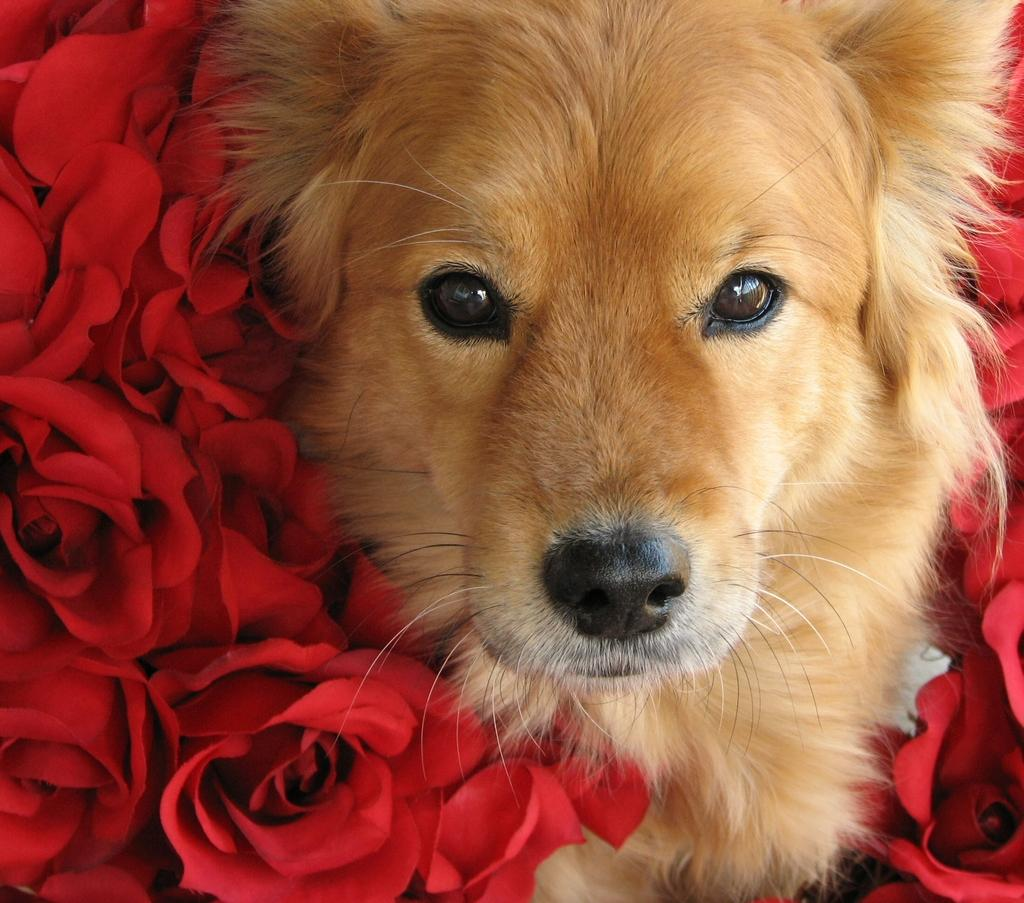What type of flowers are in the image? There are roses in the image. What type of animal is in the image? There is a dog in the image. What type of gardening tool is visible in the image? There is no gardening tool visible in the image. What type of plant is depicted with the roses in the image? There is no other plant depicted with the roses in the image. 